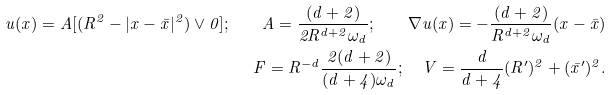Convert formula to latex. <formula><loc_0><loc_0><loc_500><loc_500>u ( x ) = A [ ( R ^ { 2 } - | x - \bar { x } | ^ { 2 } ) \vee 0 ] ; \quad A = \frac { ( d + 2 ) } { 2 R ^ { d + 2 } \omega _ { d } } ; \quad \nabla u ( x ) = - \frac { ( d + 2 ) } { R ^ { d + 2 } \omega _ { d } } ( x - \bar { x } ) \\ F = R ^ { - d } \frac { 2 ( d + 2 ) } { ( d + 4 ) \omega _ { d } } ; \quad V = \frac { d } { d + 4 } ( R ^ { \prime } ) ^ { 2 } + ( \bar { x } ^ { \prime } ) ^ { 2 } .</formula> 